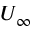<formula> <loc_0><loc_0><loc_500><loc_500>U _ { \infty }</formula> 